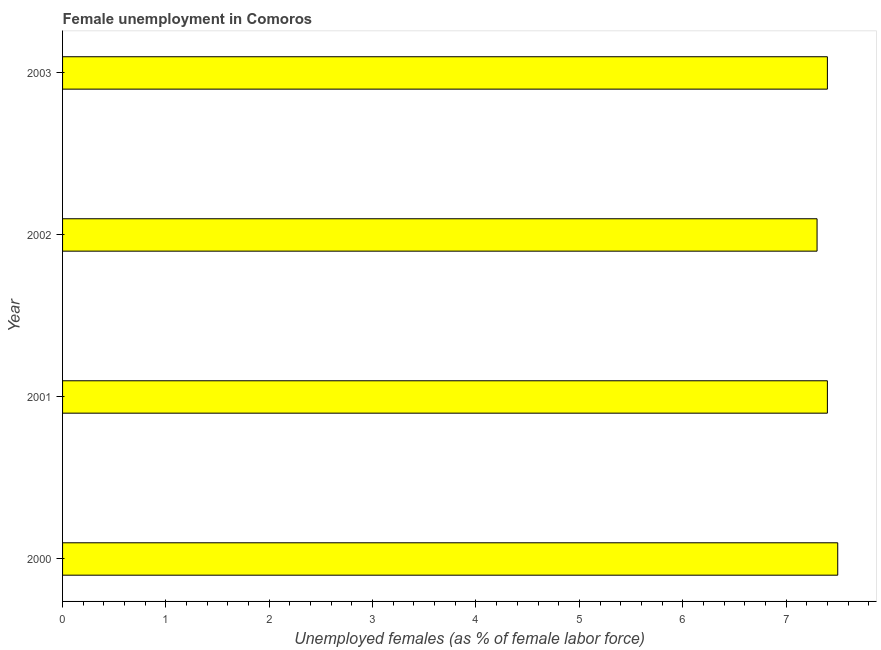Does the graph contain any zero values?
Keep it short and to the point. No. Does the graph contain grids?
Provide a succinct answer. No. What is the title of the graph?
Provide a succinct answer. Female unemployment in Comoros. What is the label or title of the X-axis?
Keep it short and to the point. Unemployed females (as % of female labor force). What is the unemployed females population in 2003?
Offer a very short reply. 7.4. Across all years, what is the maximum unemployed females population?
Provide a succinct answer. 7.5. Across all years, what is the minimum unemployed females population?
Your response must be concise. 7.3. In which year was the unemployed females population minimum?
Offer a terse response. 2002. What is the sum of the unemployed females population?
Offer a terse response. 29.6. What is the average unemployed females population per year?
Your response must be concise. 7.4. What is the median unemployed females population?
Provide a succinct answer. 7.4. What is the ratio of the unemployed females population in 2000 to that in 2002?
Your answer should be compact. 1.03. Is the unemployed females population in 2002 less than that in 2003?
Offer a terse response. Yes. Is the difference between the unemployed females population in 2001 and 2003 greater than the difference between any two years?
Your answer should be compact. No. Is the sum of the unemployed females population in 2001 and 2003 greater than the maximum unemployed females population across all years?
Your response must be concise. Yes. What is the difference between the highest and the lowest unemployed females population?
Provide a succinct answer. 0.2. How many bars are there?
Your answer should be very brief. 4. Are all the bars in the graph horizontal?
Provide a succinct answer. Yes. How many years are there in the graph?
Give a very brief answer. 4. Are the values on the major ticks of X-axis written in scientific E-notation?
Provide a succinct answer. No. What is the Unemployed females (as % of female labor force) in 2001?
Your response must be concise. 7.4. What is the Unemployed females (as % of female labor force) in 2002?
Offer a terse response. 7.3. What is the Unemployed females (as % of female labor force) of 2003?
Keep it short and to the point. 7.4. What is the difference between the Unemployed females (as % of female labor force) in 2000 and 2001?
Offer a very short reply. 0.1. What is the difference between the Unemployed females (as % of female labor force) in 2000 and 2003?
Provide a short and direct response. 0.1. What is the difference between the Unemployed females (as % of female labor force) in 2001 and 2002?
Give a very brief answer. 0.1. What is the difference between the Unemployed females (as % of female labor force) in 2002 and 2003?
Your response must be concise. -0.1. What is the ratio of the Unemployed females (as % of female labor force) in 2000 to that in 2001?
Make the answer very short. 1.01. What is the ratio of the Unemployed females (as % of female labor force) in 2000 to that in 2003?
Keep it short and to the point. 1.01. What is the ratio of the Unemployed females (as % of female labor force) in 2002 to that in 2003?
Provide a short and direct response. 0.99. 